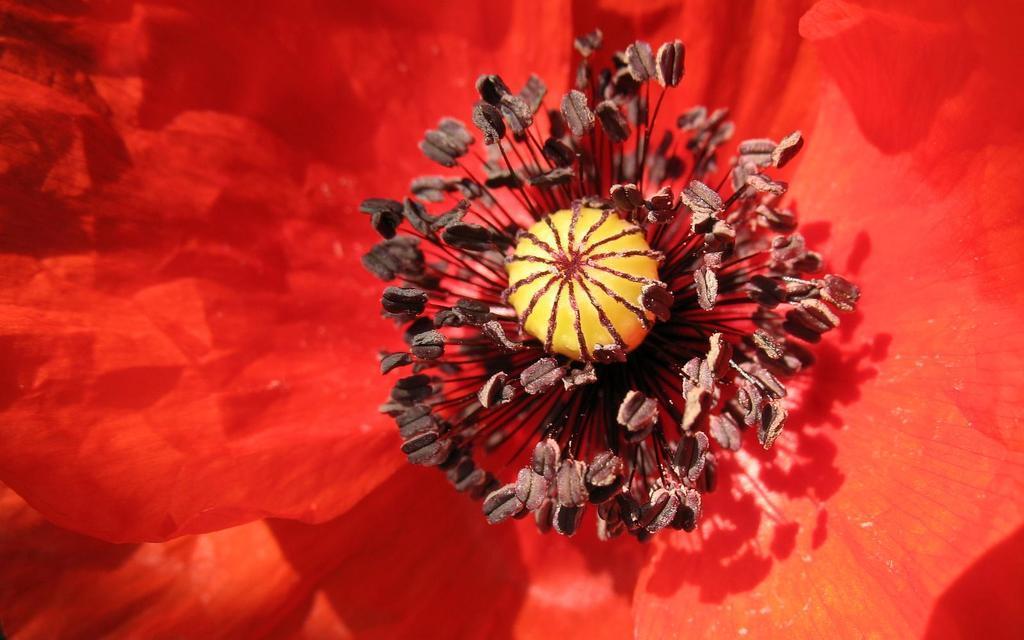Please provide a concise description of this image. In this image there is a red flower. In the red flower there is a stigma and there are pollen grains around it. At the bottom there are petals of the flower. 